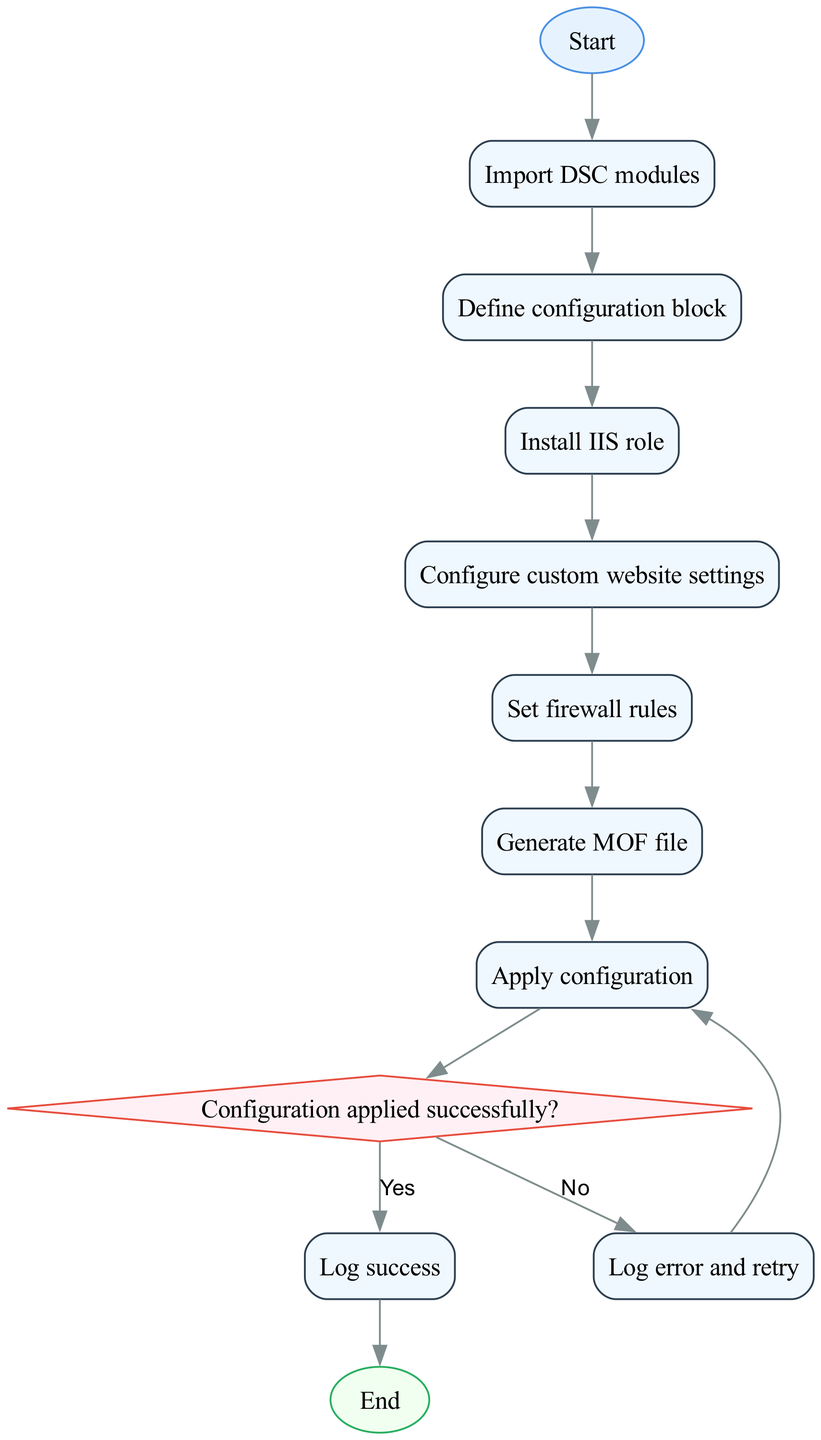What is the first step in the DSC configuration process? The first step in the process, as indicated in the diagram, is labeled "Start," which subsequently leads to the next action of importing DSC modules.
Answer: Start How many processes are in the configuration flow? By reviewing the flowchart, we can identify that there are a total of 8 process nodes in the configuration flow, from importing DSC modules to applying configuration.
Answer: 8 What is the last step before the configuration ends? The last step before the configuration ends is "Log success," which occurs if the configuration is applied successfully.
Answer: Log success Which process comes after configuring custom website settings? After the "Configure custom website settings" process, the next process depicted in the flowchart is "Set firewall rules."
Answer: Set firewall rules What happens if the configuration is not applied successfully? If the configuration is not applied successfully, indicated by the "No" branch from the decision node, the next action is to "Log error and retry," leading back to the "Apply configuration" process.
Answer: Log error and retry How many decision points are there in the diagram? The flowchart contains one decision point, which checks if the configuration was applied successfully. This node leads to two different paths based on the outcome.
Answer: 1 Which module is installed during the configuration process? The "Install IIS role" process indicates the specific module being installed during the configuration process.
Answer: IIS role What does the abbreviation MOF stand for in this context? The "Generate MOF file" node refers to a configuration file, where MOF stands for Management Object Format, used in DSC for deployment configurations.
Answer: Management Object Format 